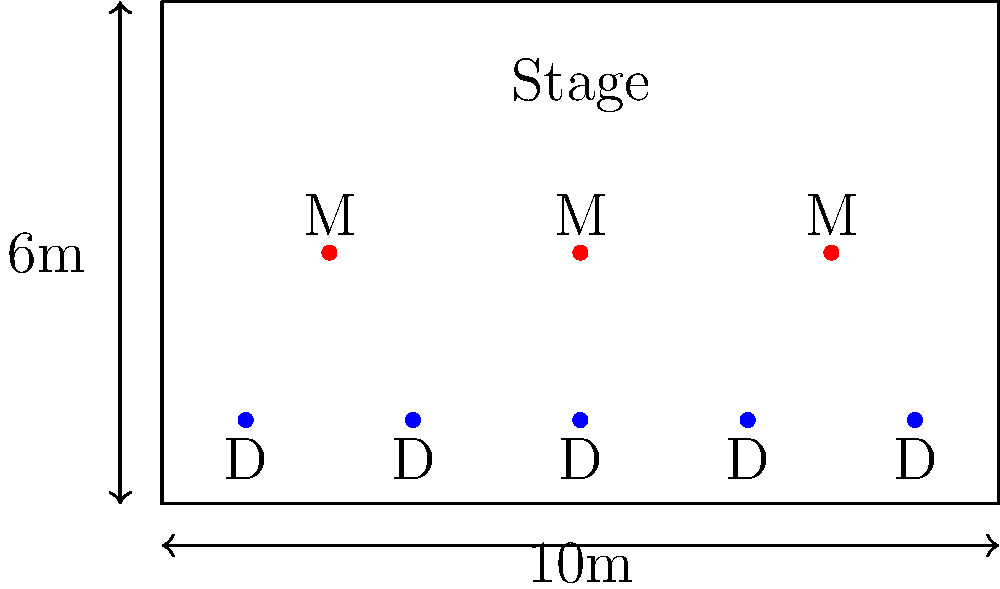As a line dance instructor, you're tasked with arranging 3 musicians (a banjo player, a fiddle player, and a guitarist) and 5 dancers on a rectangular stage measuring 10m x 6m. The musicians need to be in a straight line, equally spaced, and centered on the stage. The dancers should be in a straight line 2m in front of the musicians, also equally spaced. What is the minimum distance between adjacent dancers, rounded to the nearest centimeter? Let's approach this step-by-step:

1) The stage is 10m wide. The musicians need to be equally spaced and centered.
   - If we divide the stage into quarters, the musicians will be at the 1/4, 2/4, and 3/4 points.
   - Their positions will be at 2.5m, 5m, and 7.5m from the left edge of the stage.

2) The dancers need to be 2m in front of the musicians.
   - If the stage is 6m deep, and the musicians are centered, they will be at the 3m mark.
   - The dancers will be at the 1m mark (2m in front of the musicians).

3) Now, we need to calculate the spacing for 5 dancers across the 10m width.
   - We need 4 equal spaces between 5 dancers.
   - Let's call the distance between dancers $x$.
   - The equation will be: $4x + 0 = 10$ (0 represents the width of the dancers, treating them as points)
   
4) Solving the equation:
   $4x = 10$
   $x = 10/4 = 2.5$

5) Therefore, the distance between adjacent dancers is 2.5m or 250cm.

Rounding to the nearest centimeter, the answer is 250cm.
Answer: 250cm 